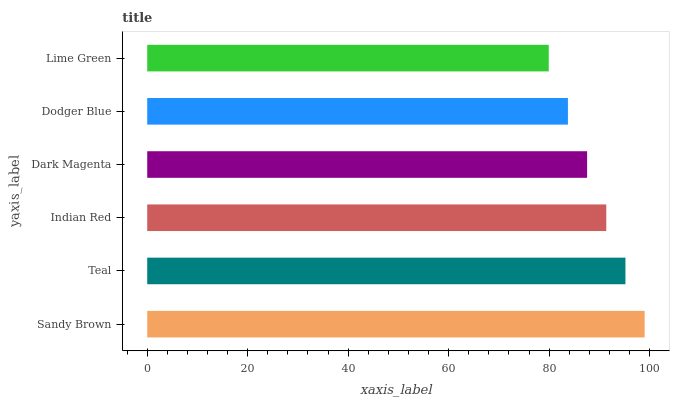Is Lime Green the minimum?
Answer yes or no. Yes. Is Sandy Brown the maximum?
Answer yes or no. Yes. Is Teal the minimum?
Answer yes or no. No. Is Teal the maximum?
Answer yes or no. No. Is Sandy Brown greater than Teal?
Answer yes or no. Yes. Is Teal less than Sandy Brown?
Answer yes or no. Yes. Is Teal greater than Sandy Brown?
Answer yes or no. No. Is Sandy Brown less than Teal?
Answer yes or no. No. Is Indian Red the high median?
Answer yes or no. Yes. Is Dark Magenta the low median?
Answer yes or no. Yes. Is Sandy Brown the high median?
Answer yes or no. No. Is Lime Green the low median?
Answer yes or no. No. 